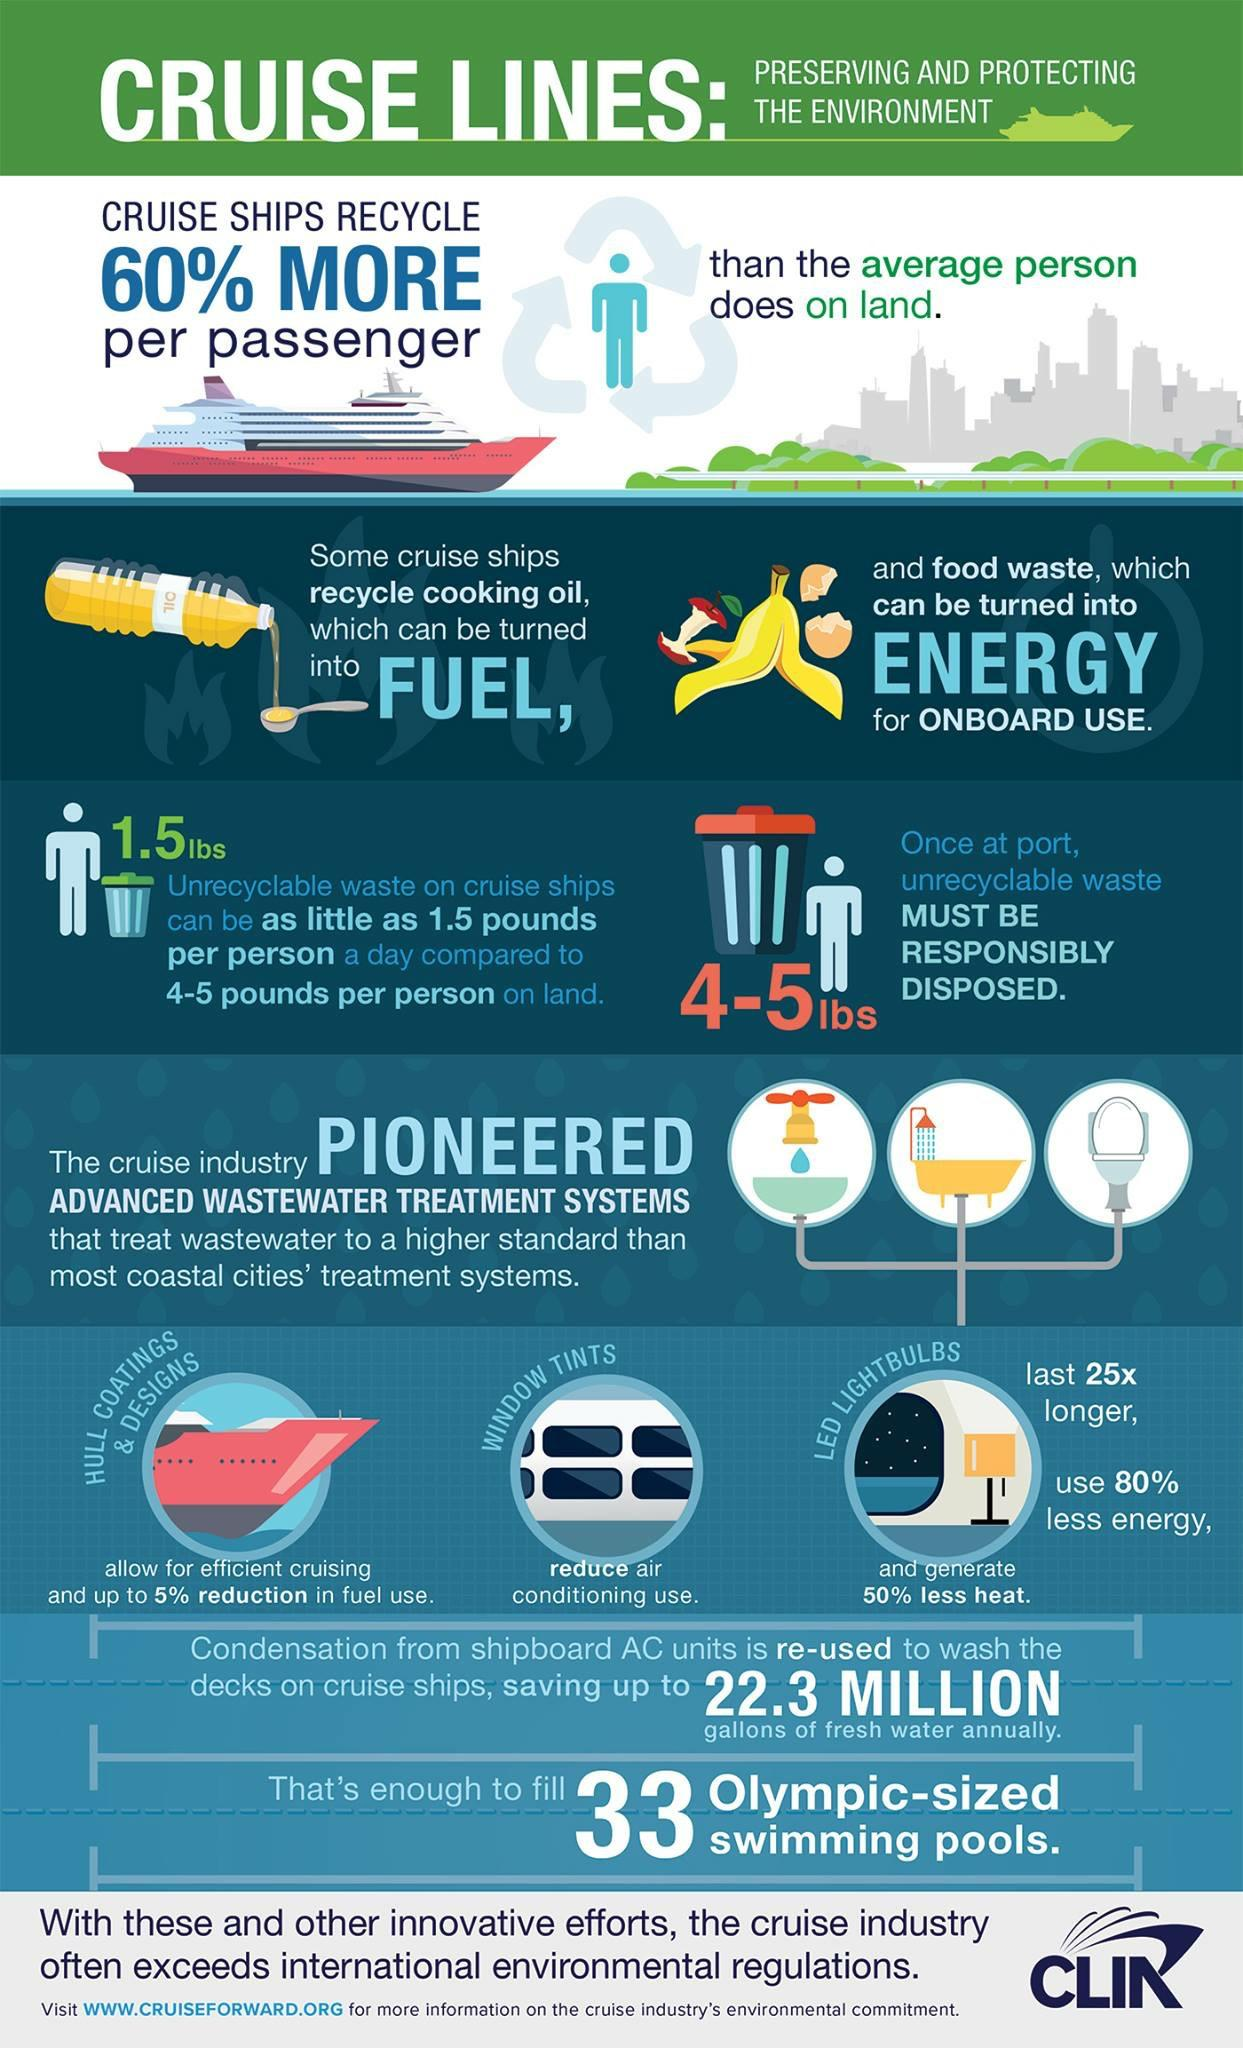Highlight a few significant elements in this photo. The use of efficient hull coatings and designs is a key factor in enabling efficient cruising. Window tints are an effective factor in reducing air conditioning usage. 